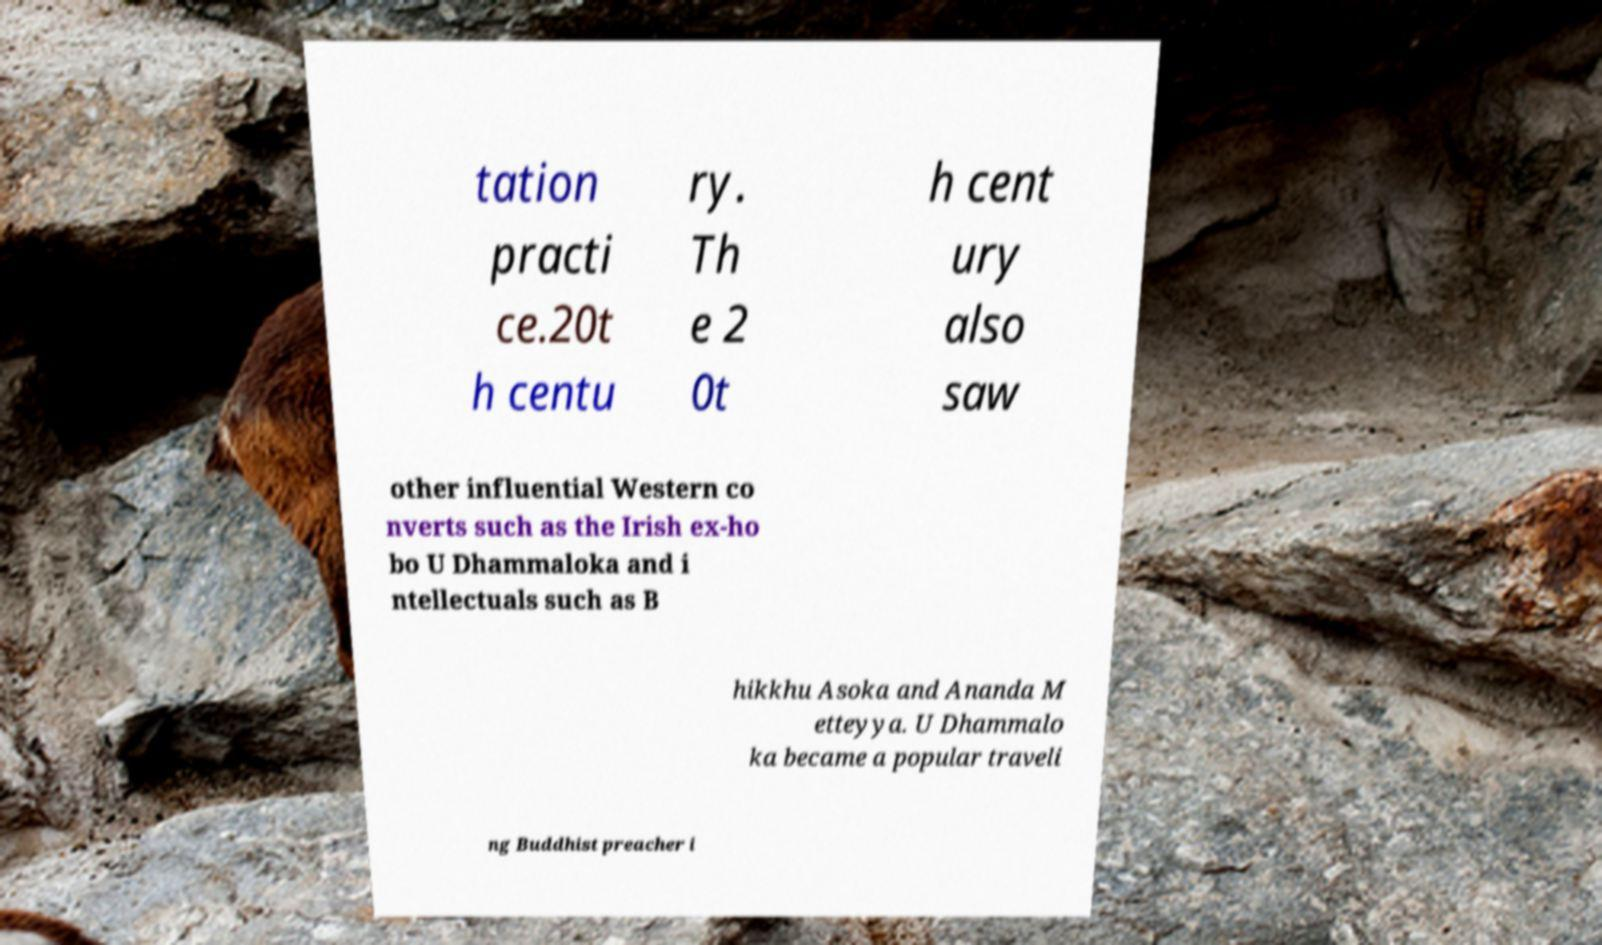Please identify and transcribe the text found in this image. tation practi ce.20t h centu ry. Th e 2 0t h cent ury also saw other influential Western co nverts such as the Irish ex-ho bo U Dhammaloka and i ntellectuals such as B hikkhu Asoka and Ananda M etteyya. U Dhammalo ka became a popular traveli ng Buddhist preacher i 